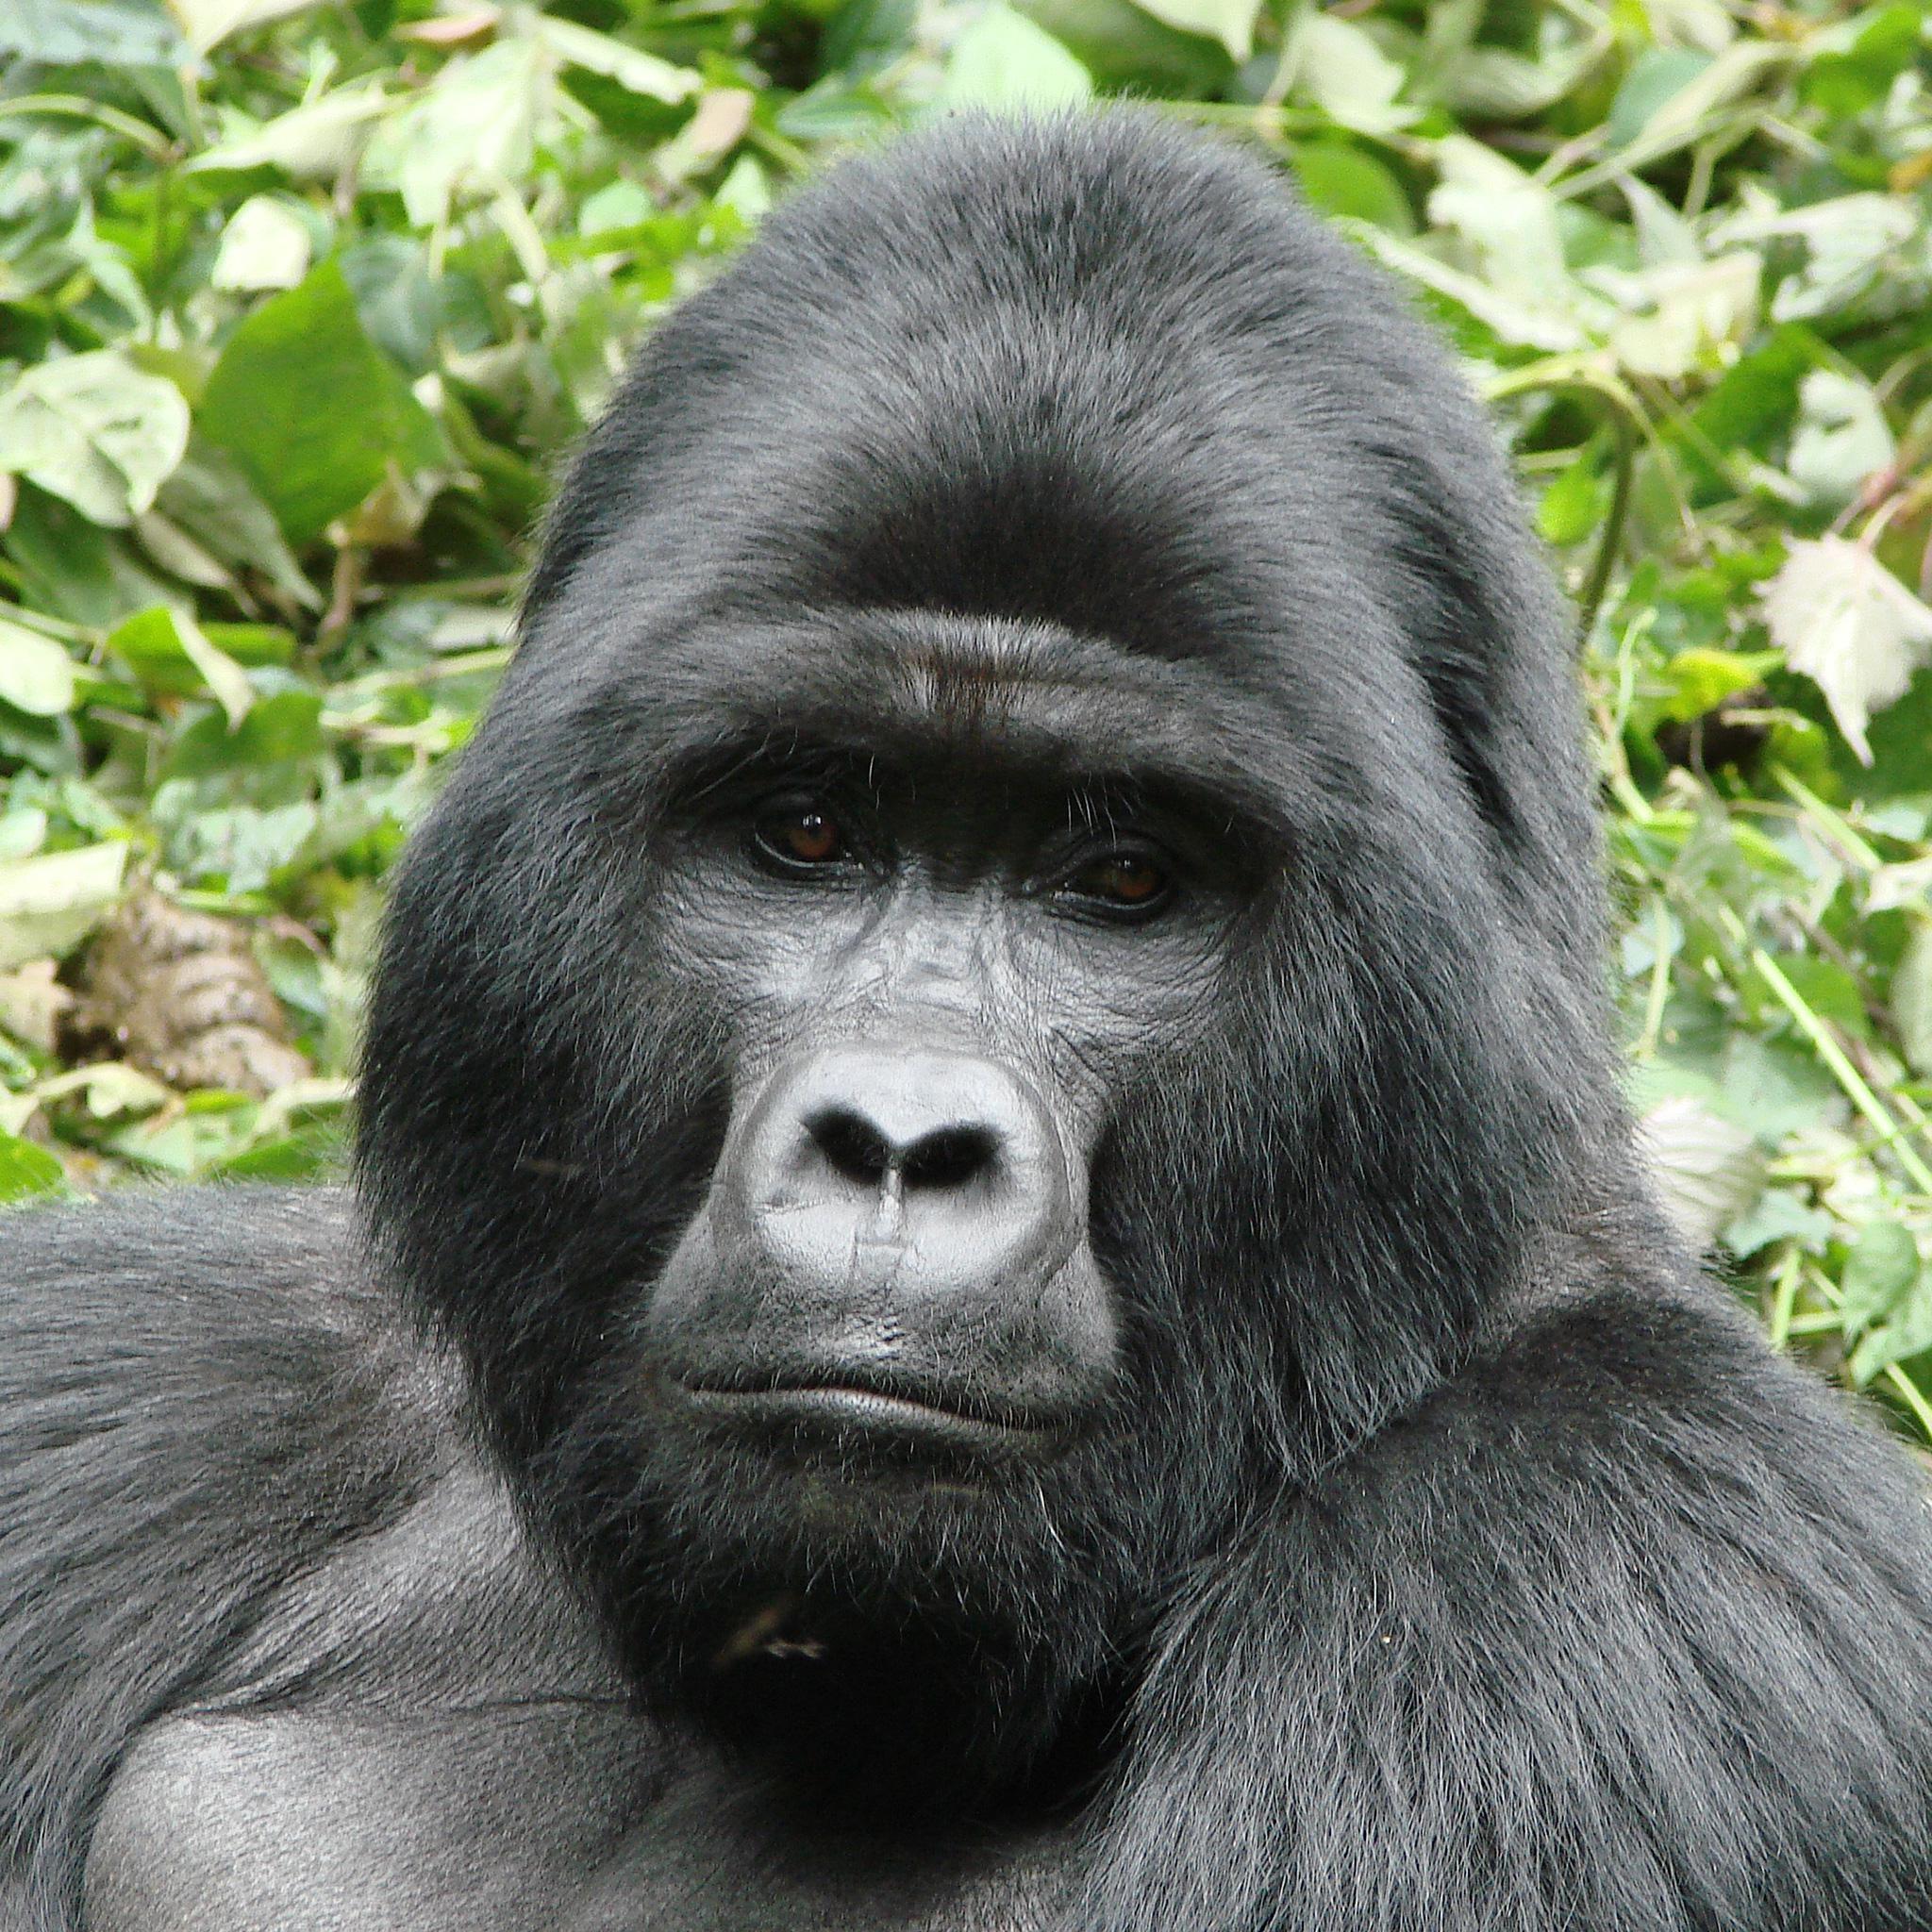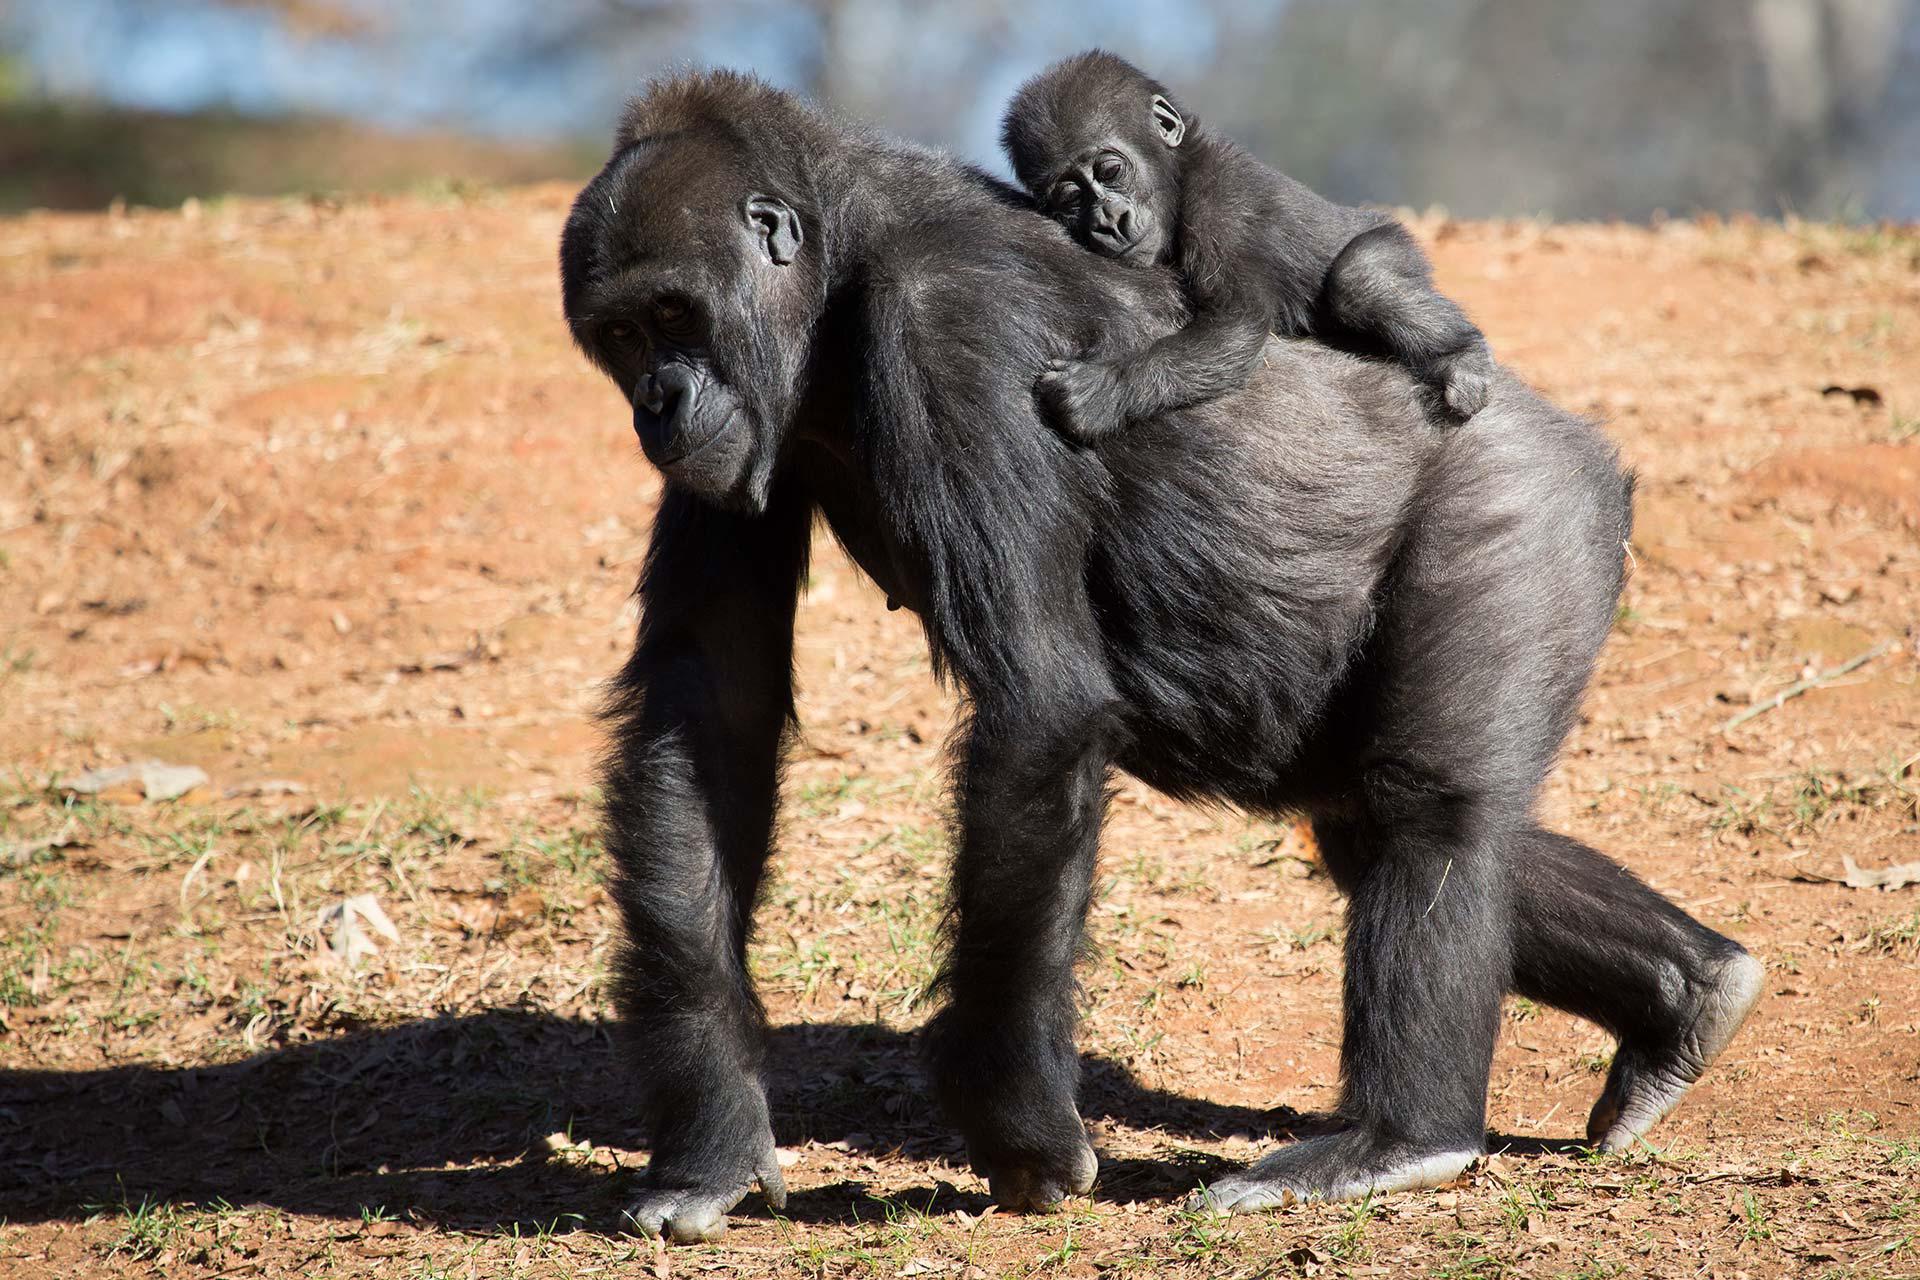The first image is the image on the left, the second image is the image on the right. For the images shown, is this caption "There is one sitting gorilla in the image on the right." true? Answer yes or no. No. 